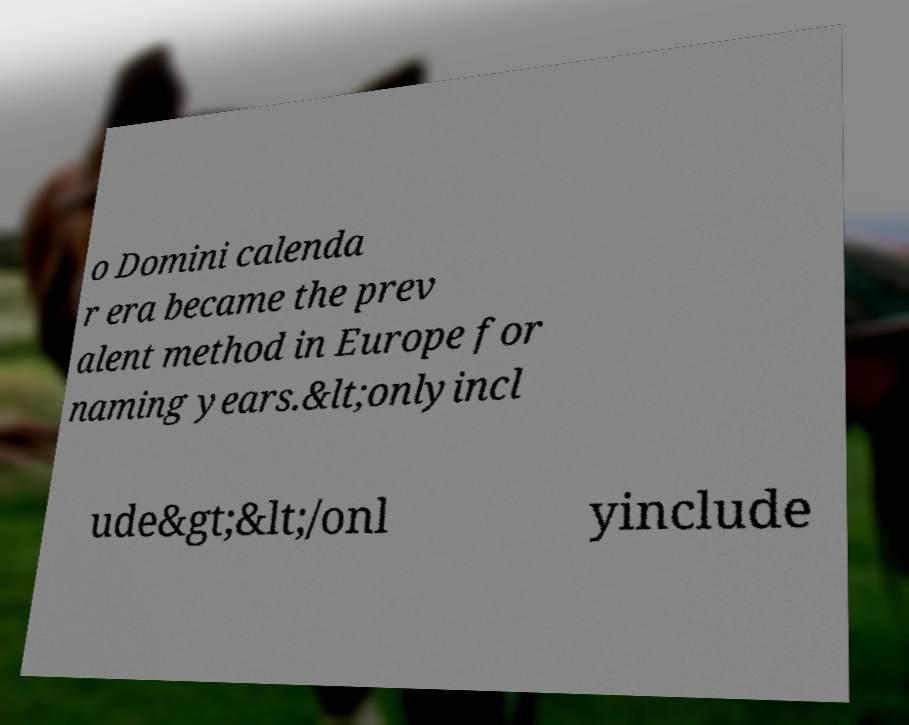Please identify and transcribe the text found in this image. o Domini calenda r era became the prev alent method in Europe for naming years.&lt;onlyincl ude&gt;&lt;/onl yinclude 